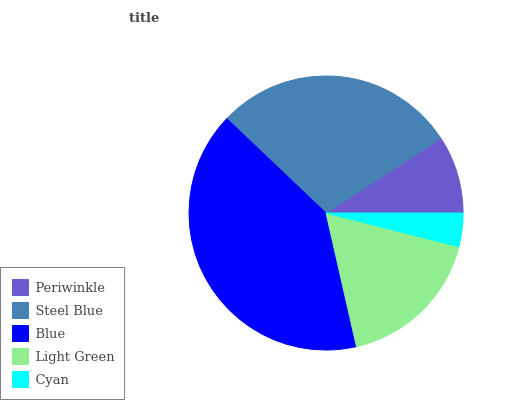Is Cyan the minimum?
Answer yes or no. Yes. Is Blue the maximum?
Answer yes or no. Yes. Is Steel Blue the minimum?
Answer yes or no. No. Is Steel Blue the maximum?
Answer yes or no. No. Is Steel Blue greater than Periwinkle?
Answer yes or no. Yes. Is Periwinkle less than Steel Blue?
Answer yes or no. Yes. Is Periwinkle greater than Steel Blue?
Answer yes or no. No. Is Steel Blue less than Periwinkle?
Answer yes or no. No. Is Light Green the high median?
Answer yes or no. Yes. Is Light Green the low median?
Answer yes or no. Yes. Is Cyan the high median?
Answer yes or no. No. Is Cyan the low median?
Answer yes or no. No. 